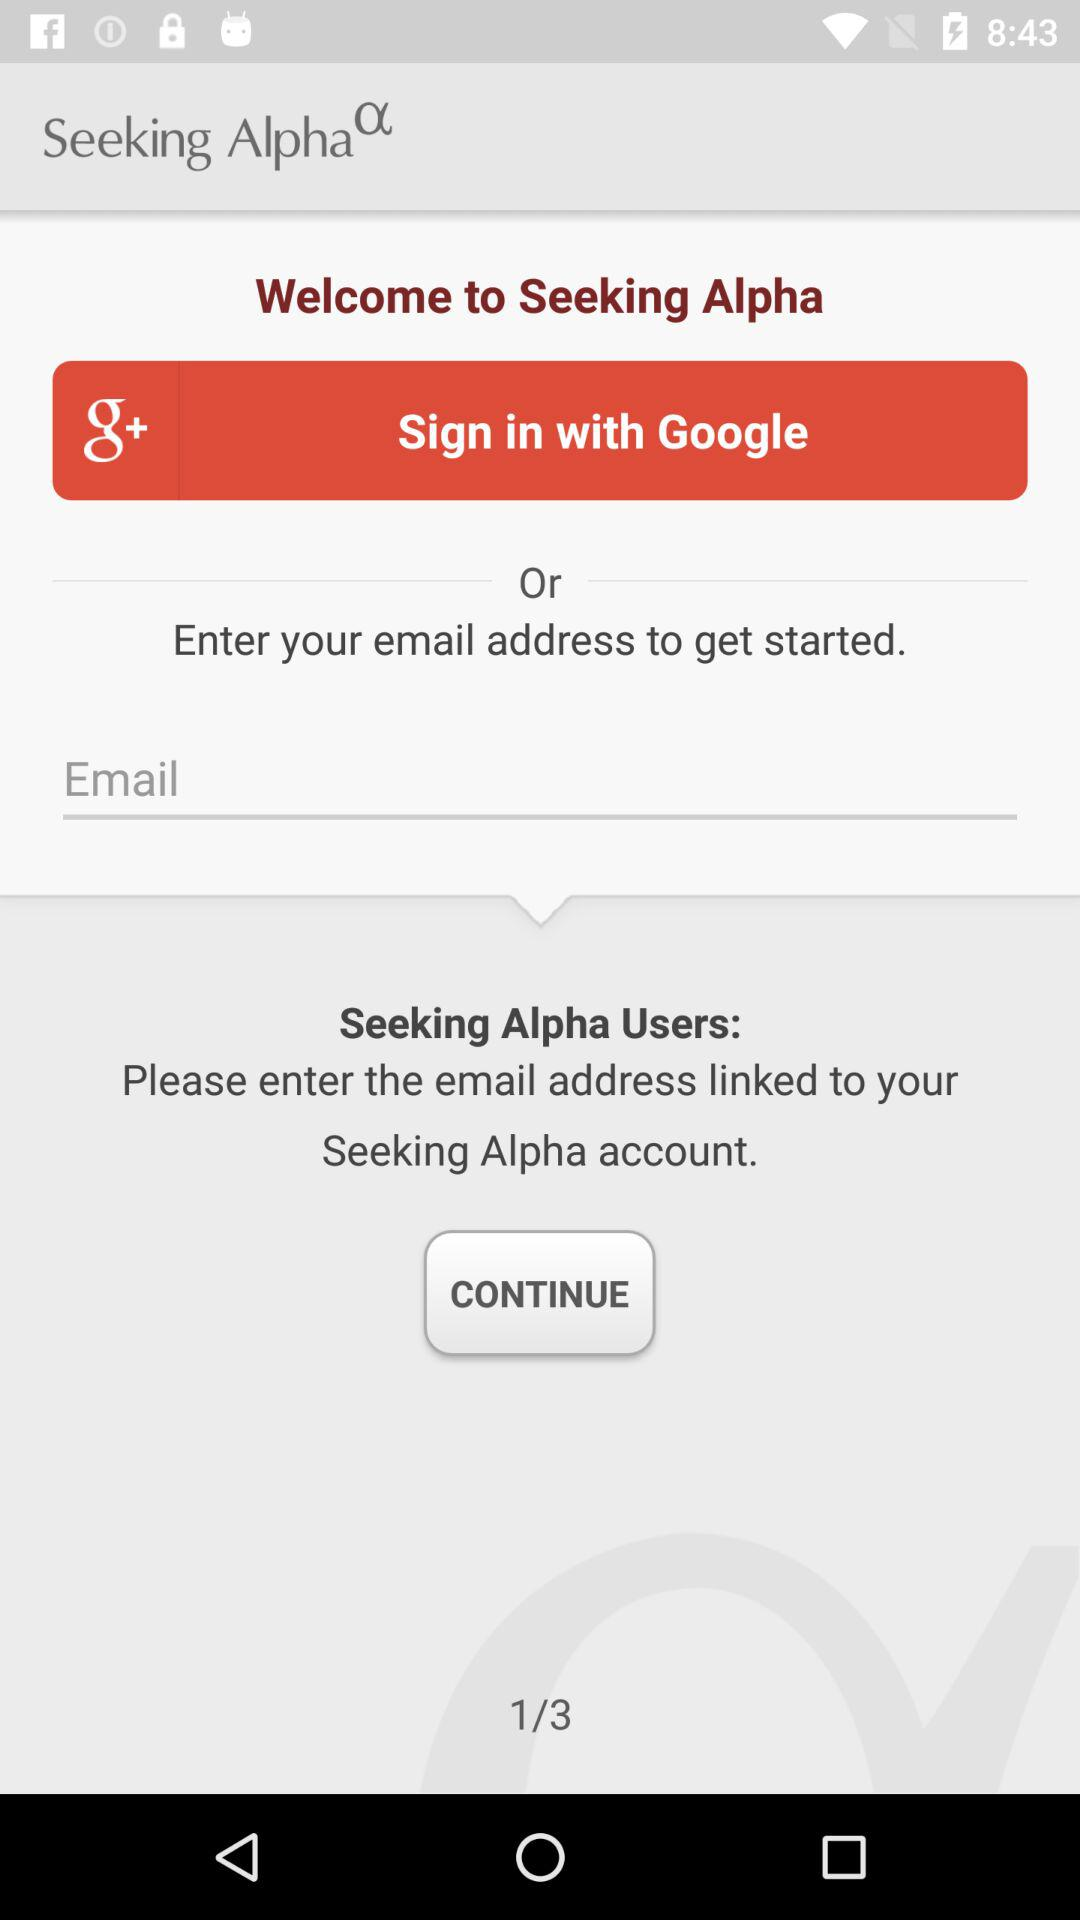At which page am I? You are at the first page. 